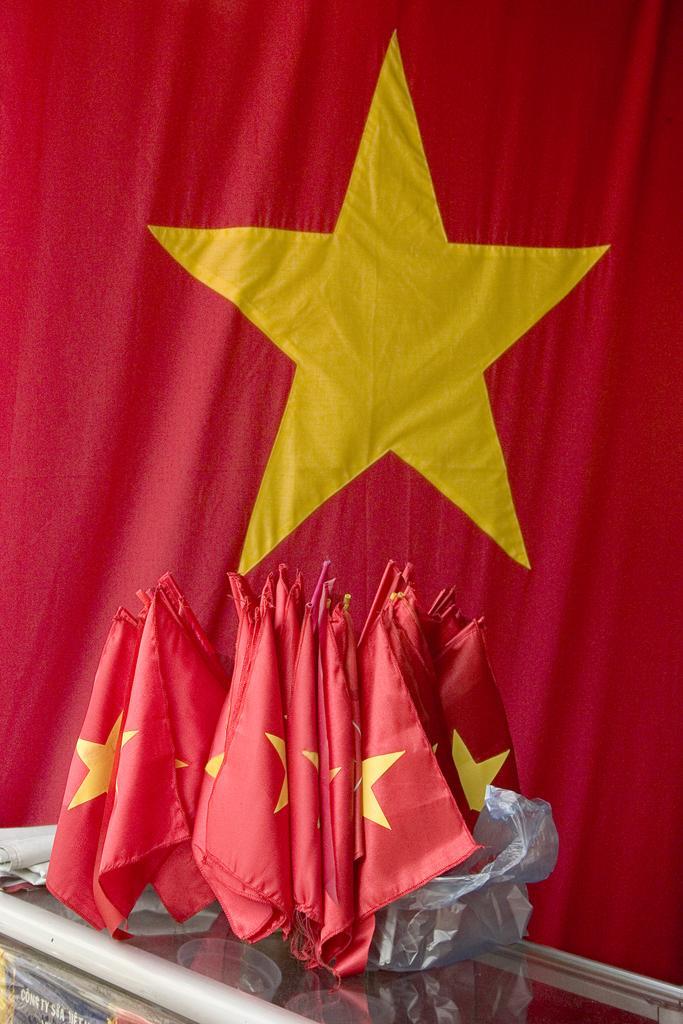Can you describe this image briefly? In this image we can see some flags on the table, also we can see a big flag behind them. 